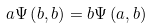<formula> <loc_0><loc_0><loc_500><loc_500>a \Psi \left ( b , b \right ) = b \Psi \left ( a , b \right )</formula> 